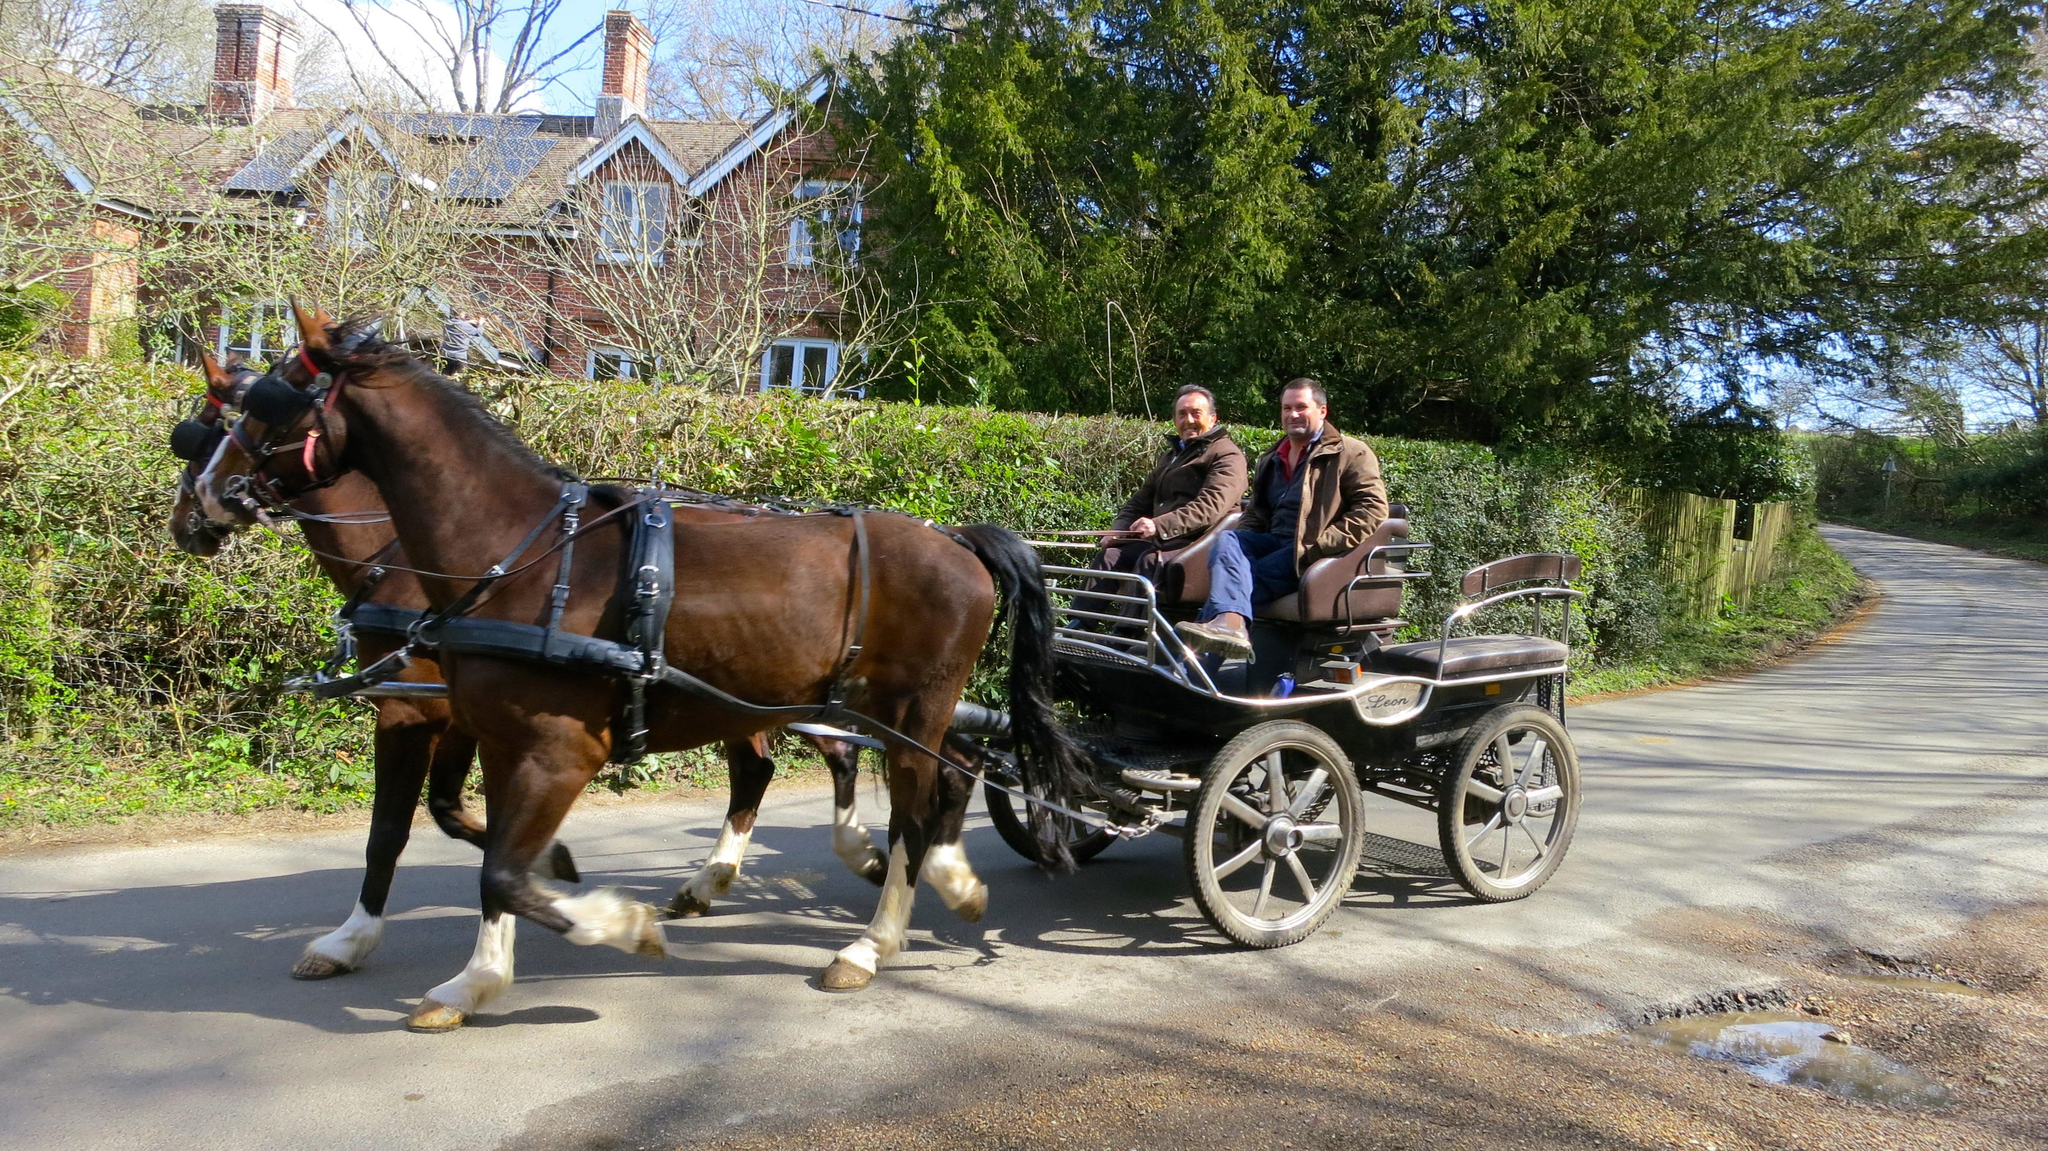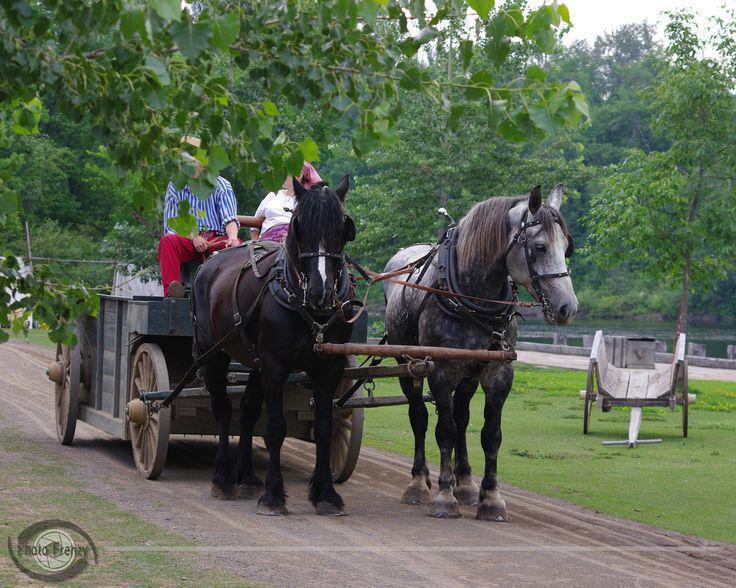The first image is the image on the left, the second image is the image on the right. Given the left and right images, does the statement "At least one image shows a cart pulled by two horses." hold true? Answer yes or no. Yes. The first image is the image on the left, the second image is the image on the right. Given the left and right images, does the statement "In one image, carts with fabric canopies are pulled through the woods along a metal track by a single horse." hold true? Answer yes or no. No. 